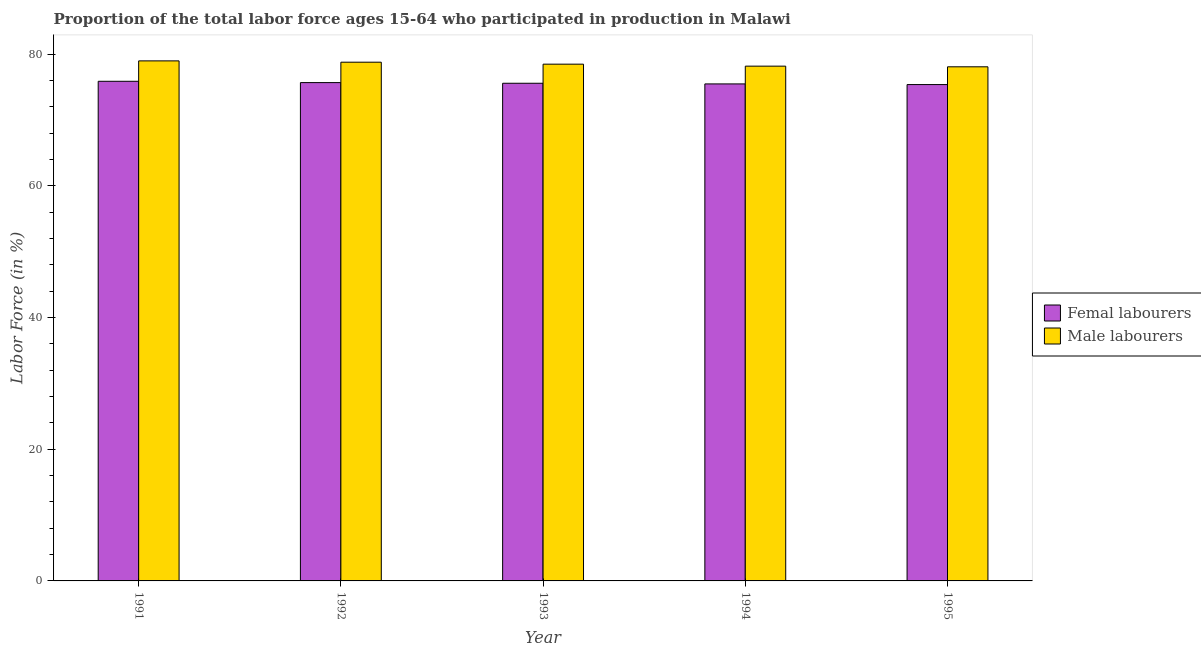How many different coloured bars are there?
Provide a succinct answer. 2. Are the number of bars per tick equal to the number of legend labels?
Give a very brief answer. Yes. Are the number of bars on each tick of the X-axis equal?
Offer a terse response. Yes. How many bars are there on the 5th tick from the left?
Your answer should be compact. 2. In how many cases, is the number of bars for a given year not equal to the number of legend labels?
Your response must be concise. 0. What is the percentage of male labour force in 1995?
Offer a terse response. 78.1. Across all years, what is the maximum percentage of female labor force?
Offer a very short reply. 75.9. Across all years, what is the minimum percentage of female labor force?
Your answer should be compact. 75.4. In which year was the percentage of male labour force maximum?
Provide a short and direct response. 1991. What is the total percentage of female labor force in the graph?
Provide a short and direct response. 378.1. What is the difference between the percentage of male labour force in 1991 and that in 1995?
Your answer should be compact. 0.9. What is the difference between the percentage of male labour force in 1993 and the percentage of female labor force in 1995?
Your response must be concise. 0.4. What is the average percentage of male labour force per year?
Provide a succinct answer. 78.52. What is the ratio of the percentage of male labour force in 1991 to that in 1992?
Your response must be concise. 1. What is the difference between the highest and the second highest percentage of male labour force?
Offer a terse response. 0.2. What is the difference between the highest and the lowest percentage of male labour force?
Provide a succinct answer. 0.9. In how many years, is the percentage of male labour force greater than the average percentage of male labour force taken over all years?
Provide a short and direct response. 2. Is the sum of the percentage of male labour force in 1993 and 1995 greater than the maximum percentage of female labor force across all years?
Keep it short and to the point. Yes. What does the 2nd bar from the left in 1992 represents?
Your response must be concise. Male labourers. What does the 1st bar from the right in 1992 represents?
Your answer should be very brief. Male labourers. Are all the bars in the graph horizontal?
Make the answer very short. No. Are the values on the major ticks of Y-axis written in scientific E-notation?
Your response must be concise. No. Does the graph contain any zero values?
Offer a very short reply. No. How many legend labels are there?
Provide a short and direct response. 2. What is the title of the graph?
Ensure brevity in your answer.  Proportion of the total labor force ages 15-64 who participated in production in Malawi. Does "Services" appear as one of the legend labels in the graph?
Give a very brief answer. No. What is the label or title of the Y-axis?
Make the answer very short. Labor Force (in %). What is the Labor Force (in %) in Femal labourers in 1991?
Your answer should be compact. 75.9. What is the Labor Force (in %) of Male labourers in 1991?
Ensure brevity in your answer.  79. What is the Labor Force (in %) in Femal labourers in 1992?
Your response must be concise. 75.7. What is the Labor Force (in %) of Male labourers in 1992?
Give a very brief answer. 78.8. What is the Labor Force (in %) of Femal labourers in 1993?
Provide a succinct answer. 75.6. What is the Labor Force (in %) in Male labourers in 1993?
Your answer should be very brief. 78.5. What is the Labor Force (in %) of Femal labourers in 1994?
Provide a succinct answer. 75.5. What is the Labor Force (in %) in Male labourers in 1994?
Offer a very short reply. 78.2. What is the Labor Force (in %) in Femal labourers in 1995?
Provide a succinct answer. 75.4. What is the Labor Force (in %) in Male labourers in 1995?
Provide a short and direct response. 78.1. Across all years, what is the maximum Labor Force (in %) of Femal labourers?
Provide a succinct answer. 75.9. Across all years, what is the maximum Labor Force (in %) of Male labourers?
Provide a succinct answer. 79. Across all years, what is the minimum Labor Force (in %) in Femal labourers?
Offer a very short reply. 75.4. Across all years, what is the minimum Labor Force (in %) of Male labourers?
Provide a short and direct response. 78.1. What is the total Labor Force (in %) in Femal labourers in the graph?
Ensure brevity in your answer.  378.1. What is the total Labor Force (in %) of Male labourers in the graph?
Offer a very short reply. 392.6. What is the difference between the Labor Force (in %) of Femal labourers in 1991 and that in 1992?
Provide a short and direct response. 0.2. What is the difference between the Labor Force (in %) in Male labourers in 1991 and that in 1993?
Ensure brevity in your answer.  0.5. What is the difference between the Labor Force (in %) in Male labourers in 1991 and that in 1994?
Your answer should be very brief. 0.8. What is the difference between the Labor Force (in %) in Male labourers in 1991 and that in 1995?
Your response must be concise. 0.9. What is the difference between the Labor Force (in %) in Male labourers in 1992 and that in 1994?
Your answer should be compact. 0.6. What is the difference between the Labor Force (in %) of Femal labourers in 1993 and that in 1995?
Offer a very short reply. 0.2. What is the difference between the Labor Force (in %) of Male labourers in 1993 and that in 1995?
Offer a very short reply. 0.4. What is the difference between the Labor Force (in %) of Femal labourers in 1994 and that in 1995?
Make the answer very short. 0.1. What is the difference between the Labor Force (in %) of Femal labourers in 1991 and the Labor Force (in %) of Male labourers in 1994?
Give a very brief answer. -2.3. What is the difference between the Labor Force (in %) of Femal labourers in 1992 and the Labor Force (in %) of Male labourers in 1995?
Ensure brevity in your answer.  -2.4. What is the difference between the Labor Force (in %) in Femal labourers in 1993 and the Labor Force (in %) in Male labourers in 1995?
Offer a terse response. -2.5. What is the average Labor Force (in %) of Femal labourers per year?
Your answer should be compact. 75.62. What is the average Labor Force (in %) in Male labourers per year?
Make the answer very short. 78.52. In the year 1991, what is the difference between the Labor Force (in %) of Femal labourers and Labor Force (in %) of Male labourers?
Provide a succinct answer. -3.1. In the year 1993, what is the difference between the Labor Force (in %) in Femal labourers and Labor Force (in %) in Male labourers?
Your answer should be very brief. -2.9. What is the ratio of the Labor Force (in %) in Male labourers in 1991 to that in 1992?
Your answer should be compact. 1. What is the ratio of the Labor Force (in %) in Femal labourers in 1991 to that in 1993?
Give a very brief answer. 1. What is the ratio of the Labor Force (in %) in Male labourers in 1991 to that in 1993?
Give a very brief answer. 1.01. What is the ratio of the Labor Force (in %) in Femal labourers in 1991 to that in 1994?
Your answer should be compact. 1.01. What is the ratio of the Labor Force (in %) in Male labourers in 1991 to that in 1994?
Your answer should be compact. 1.01. What is the ratio of the Labor Force (in %) in Femal labourers in 1991 to that in 1995?
Make the answer very short. 1.01. What is the ratio of the Labor Force (in %) of Male labourers in 1991 to that in 1995?
Provide a succinct answer. 1.01. What is the ratio of the Labor Force (in %) of Femal labourers in 1992 to that in 1993?
Your answer should be compact. 1. What is the ratio of the Labor Force (in %) of Male labourers in 1992 to that in 1993?
Your response must be concise. 1. What is the ratio of the Labor Force (in %) of Femal labourers in 1992 to that in 1994?
Offer a very short reply. 1. What is the ratio of the Labor Force (in %) of Male labourers in 1992 to that in 1994?
Offer a very short reply. 1.01. What is the ratio of the Labor Force (in %) of Femal labourers in 1992 to that in 1995?
Ensure brevity in your answer.  1. What is the ratio of the Labor Force (in %) of Male labourers in 1992 to that in 1995?
Offer a terse response. 1.01. What is the ratio of the Labor Force (in %) of Femal labourers in 1993 to that in 1994?
Your answer should be compact. 1. What is the ratio of the Labor Force (in %) of Male labourers in 1993 to that in 1995?
Provide a short and direct response. 1.01. What is the ratio of the Labor Force (in %) of Femal labourers in 1994 to that in 1995?
Offer a terse response. 1. What is the ratio of the Labor Force (in %) of Male labourers in 1994 to that in 1995?
Your answer should be compact. 1. What is the difference between the highest and the second highest Labor Force (in %) of Femal labourers?
Your response must be concise. 0.2. What is the difference between the highest and the lowest Labor Force (in %) of Male labourers?
Ensure brevity in your answer.  0.9. 